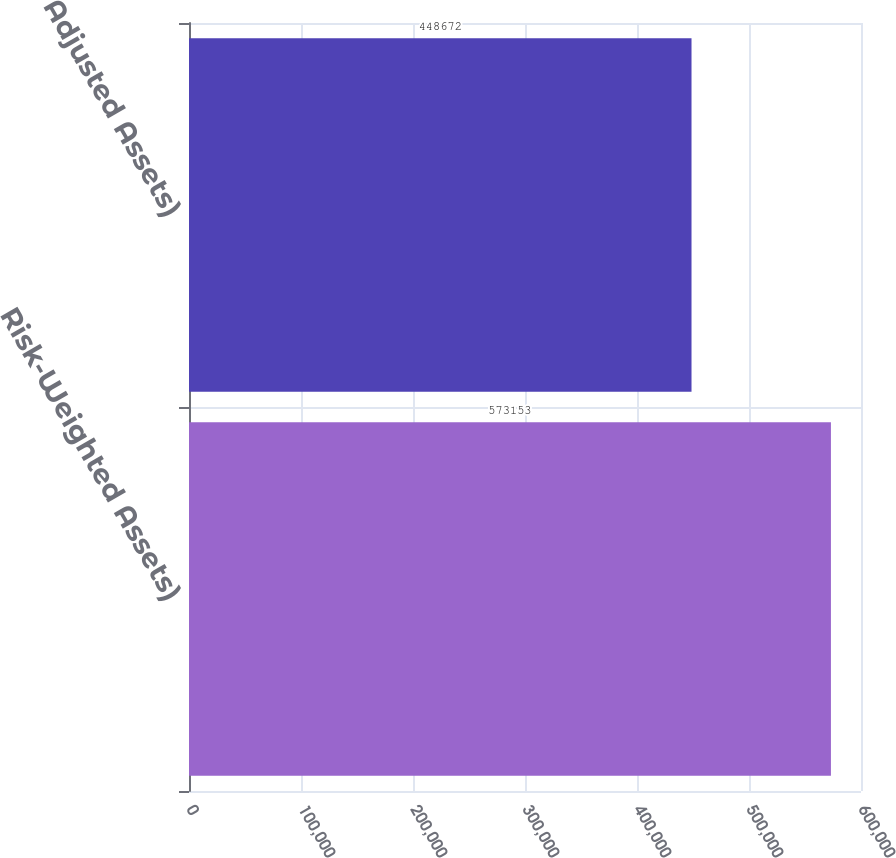<chart> <loc_0><loc_0><loc_500><loc_500><bar_chart><fcel>Risk-Weighted Assets)<fcel>Adjusted Assets)<nl><fcel>573153<fcel>448672<nl></chart> 